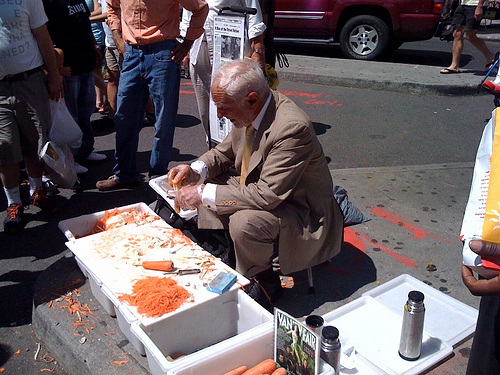<image>What color is the spray paint? I am not sure what color is the spray paint. It can be seen as red or orange. What color is the spray paint? I don't know what color the spray paint is. It can be either orange or red. 